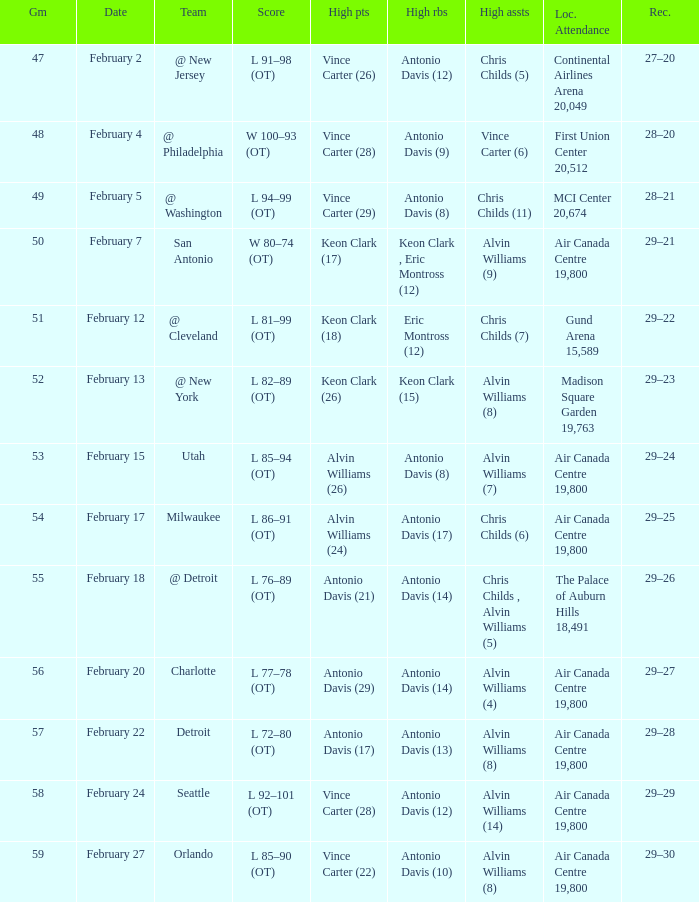What is the Team with a game of more than 56, and the score is l 85–90 (ot)? Orlando. 